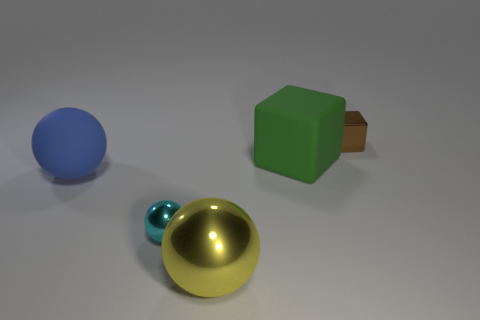Add 2 large cubes. How many objects exist? 7 Subtract all spheres. How many objects are left? 2 Subtract all brown matte things. Subtract all green rubber blocks. How many objects are left? 4 Add 3 green cubes. How many green cubes are left? 4 Add 5 small brown cylinders. How many small brown cylinders exist? 5 Subtract 0 cyan cylinders. How many objects are left? 5 